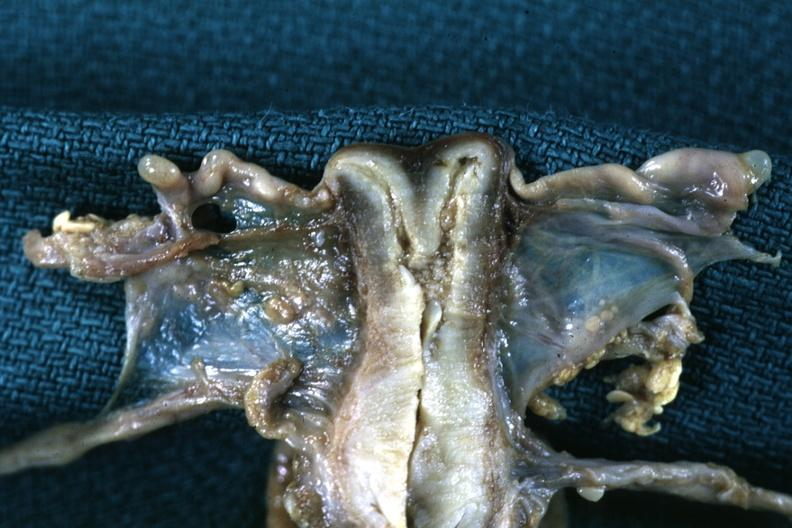what is present?
Answer the question using a single word or phrase. Female reproductive 